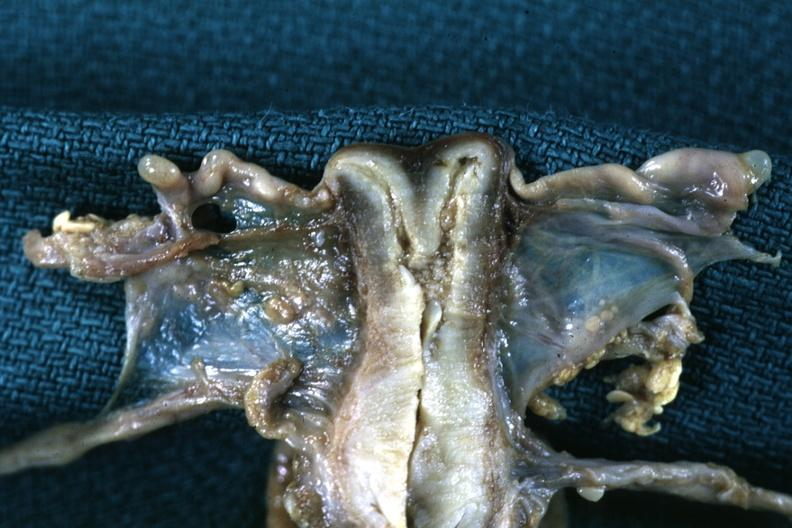what is present?
Answer the question using a single word or phrase. Female reproductive 